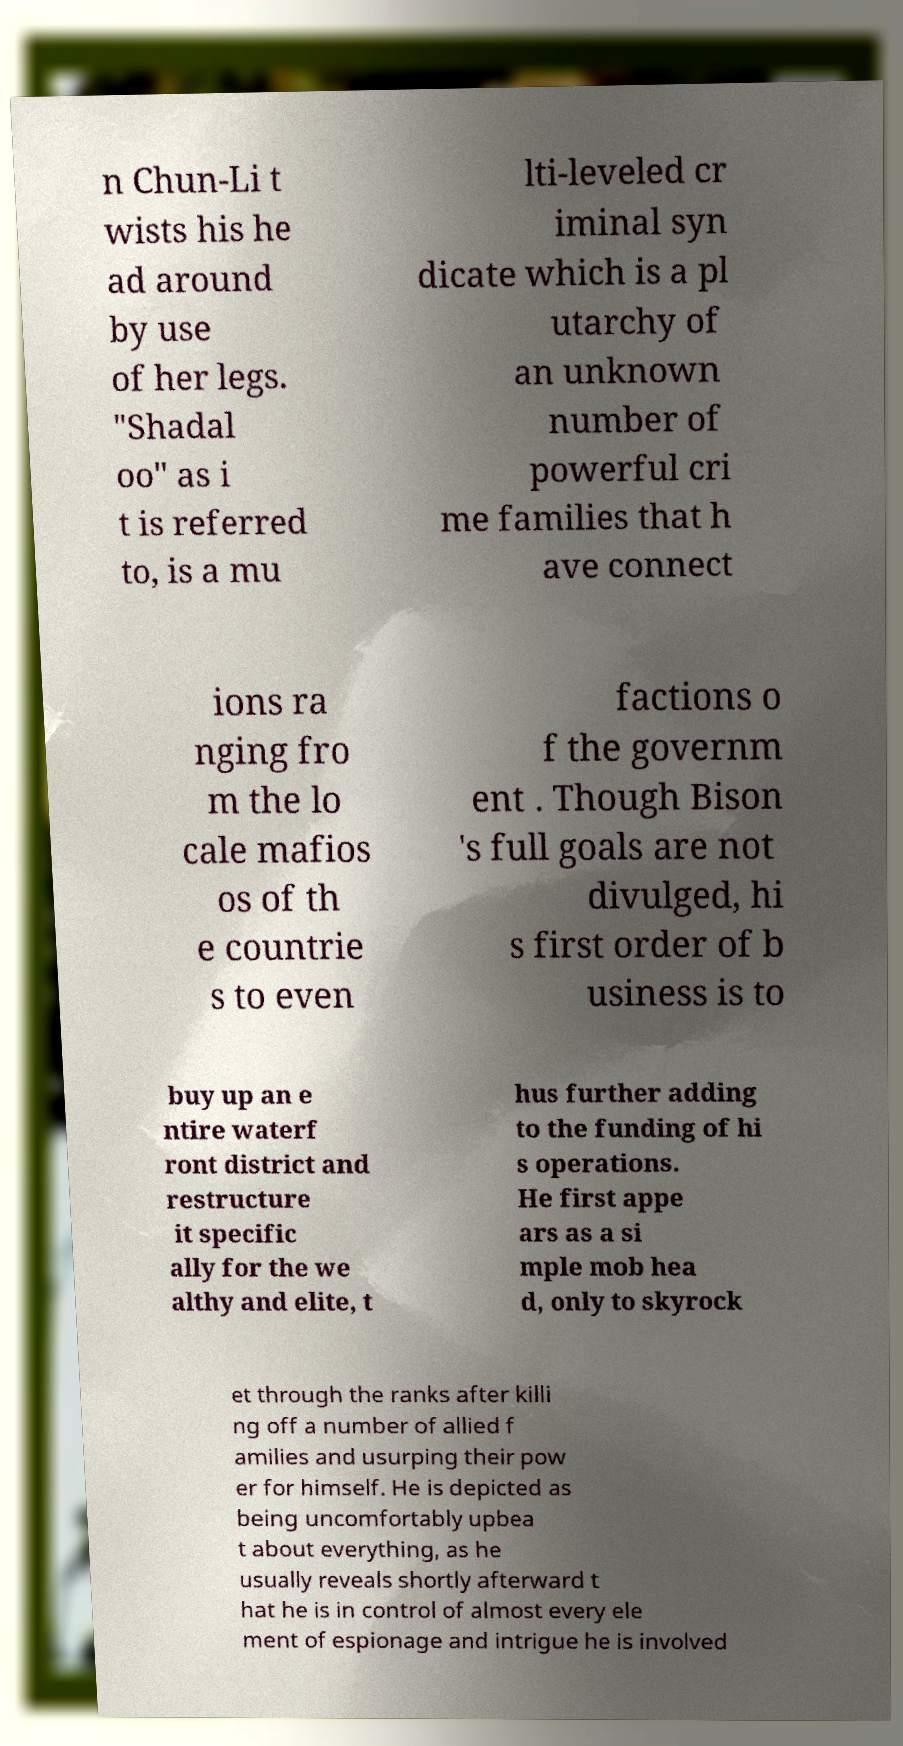Please read and relay the text visible in this image. What does it say? n Chun-Li t wists his he ad around by use of her legs. "Shadal oo" as i t is referred to, is a mu lti-leveled cr iminal syn dicate which is a pl utarchy of an unknown number of powerful cri me families that h ave connect ions ra nging fro m the lo cale mafios os of th e countrie s to even factions o f the governm ent . Though Bison 's full goals are not divulged, hi s first order of b usiness is to buy up an e ntire waterf ront district and restructure it specific ally for the we althy and elite, t hus further adding to the funding of hi s operations. He first appe ars as a si mple mob hea d, only to skyrock et through the ranks after killi ng off a number of allied f amilies and usurping their pow er for himself. He is depicted as being uncomfortably upbea t about everything, as he usually reveals shortly afterward t hat he is in control of almost every ele ment of espionage and intrigue he is involved 